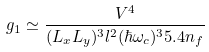<formula> <loc_0><loc_0><loc_500><loc_500>g _ { 1 } \simeq \frac { V ^ { 4 } } { ( L _ { x } L _ { y } ) ^ { 3 } l ^ { 2 } ( \hbar { \omega } _ { c } ) ^ { 3 } 5 . 4 n _ { f } }</formula> 